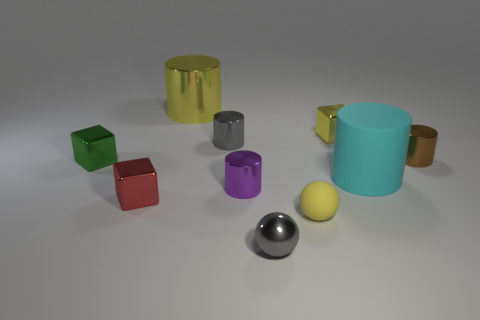Are there an equal number of large objects behind the tiny brown metallic object and matte cylinders?
Offer a very short reply. Yes. What number of things are either big objects that are behind the cyan cylinder or big cylinders?
Provide a succinct answer. 2. What shape is the yellow object that is both on the right side of the purple metal cylinder and behind the tiny red cube?
Provide a succinct answer. Cube. How many things are tiny metallic cylinders on the left side of the tiny brown cylinder or objects in front of the green object?
Your answer should be compact. 6. How many other objects are there of the same size as the yellow matte object?
Your answer should be very brief. 7. Do the cube that is to the right of the large metal cylinder and the large shiny cylinder have the same color?
Offer a very short reply. Yes. What is the size of the thing that is on the right side of the gray metallic sphere and in front of the tiny red shiny object?
Make the answer very short. Small. What number of small things are either green cubes or brown cylinders?
Provide a succinct answer. 2. What shape is the yellow metal thing that is on the left side of the tiny yellow metallic cube?
Provide a succinct answer. Cylinder. How many big blue metallic balls are there?
Ensure brevity in your answer.  0. 